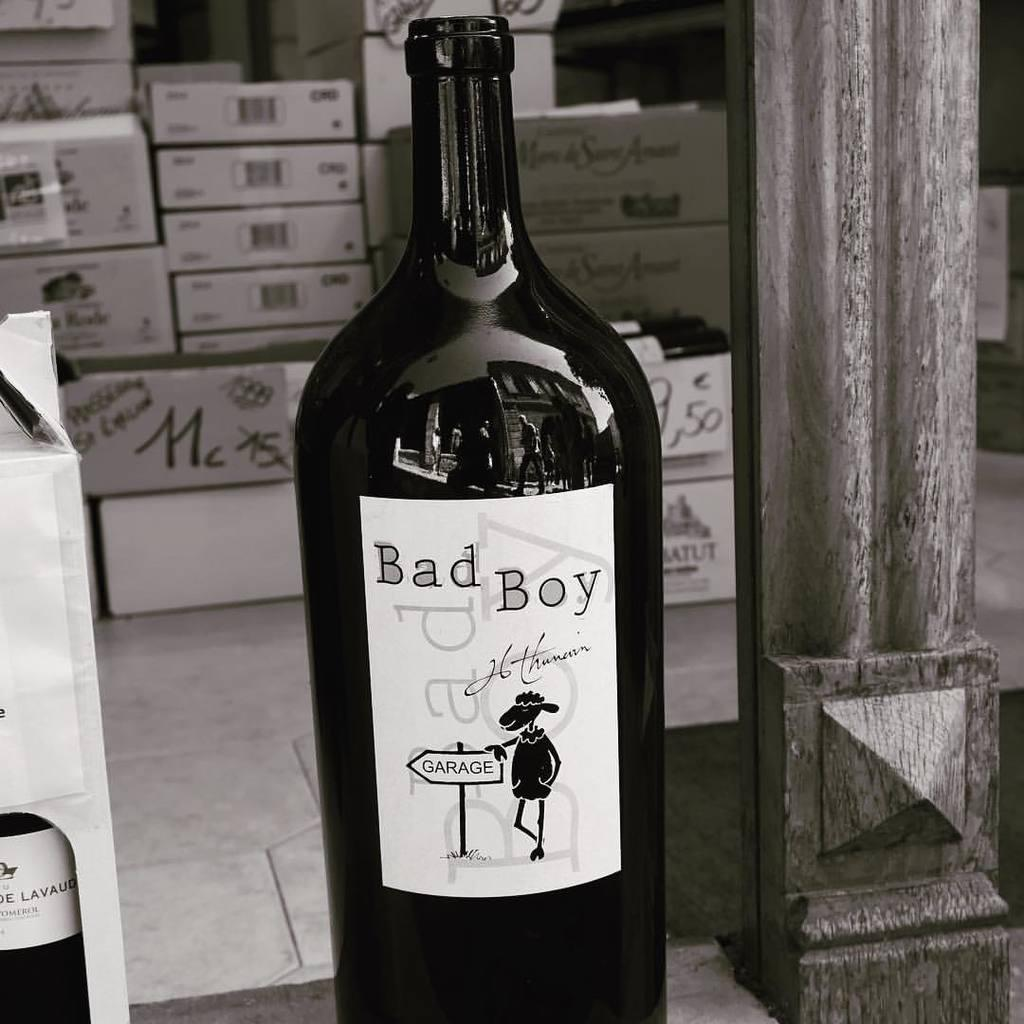<image>
Present a compact description of the photo's key features. A wine bottle with the label of "Bad Boy" also shows a picture of a sheep standing next to a sign that says "garage." 